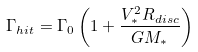Convert formula to latex. <formula><loc_0><loc_0><loc_500><loc_500>\Gamma _ { h i t } = \Gamma _ { 0 } \left ( 1 + \frac { V ^ { 2 } _ { * } R _ { d i s c } } { G M _ { * } } \right )</formula> 